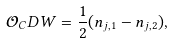Convert formula to latex. <formula><loc_0><loc_0><loc_500><loc_500>\mathcal { O } _ { C } D W = \frac { 1 } { 2 } ( n _ { j , 1 } - n _ { j , 2 } ) ,</formula> 